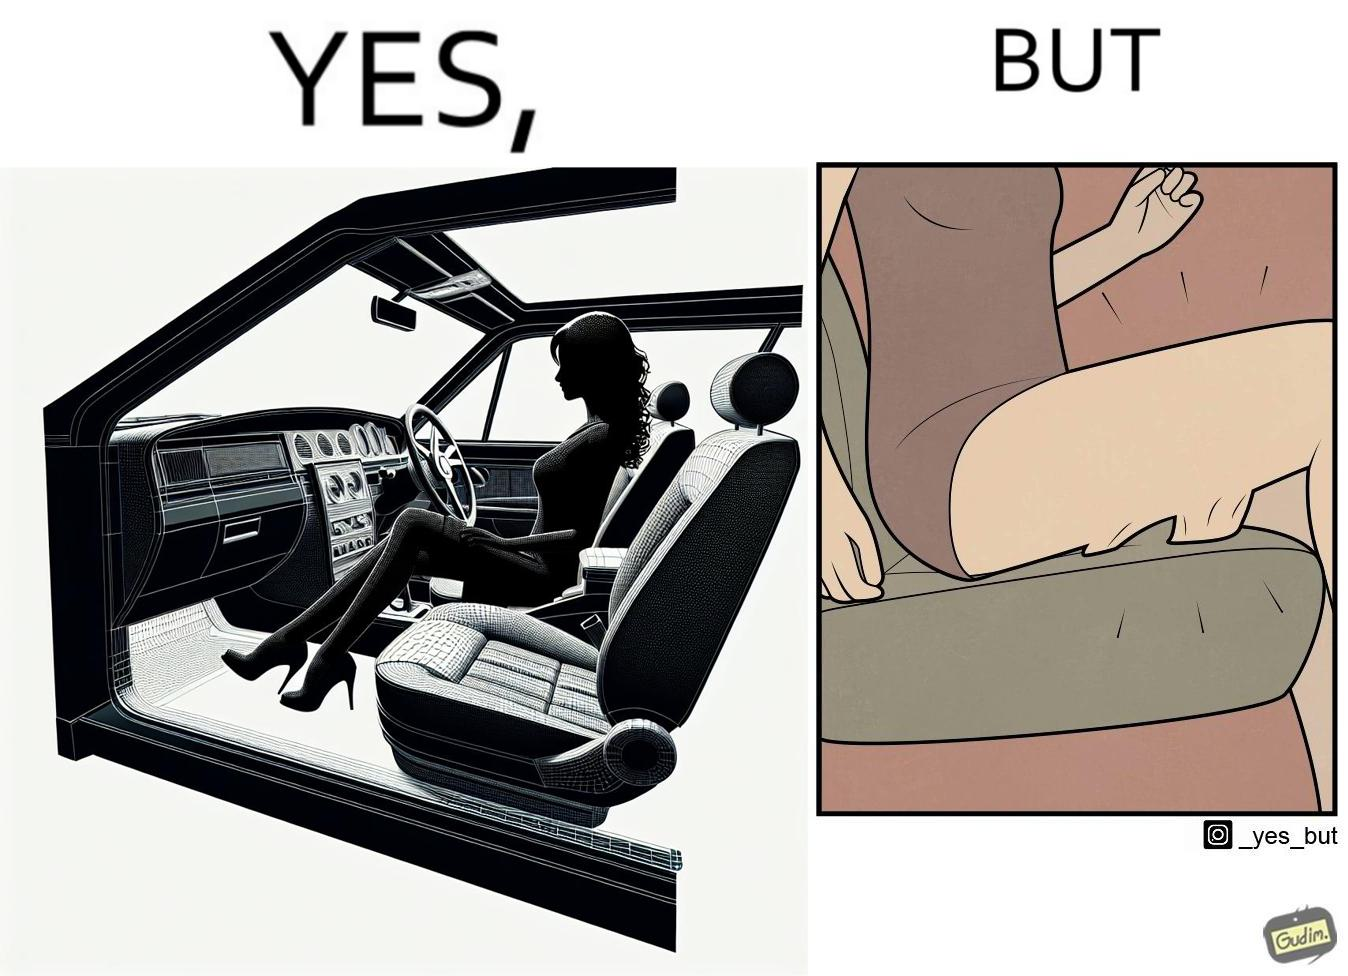Is this a satirical image? Yes, this image is satirical. 